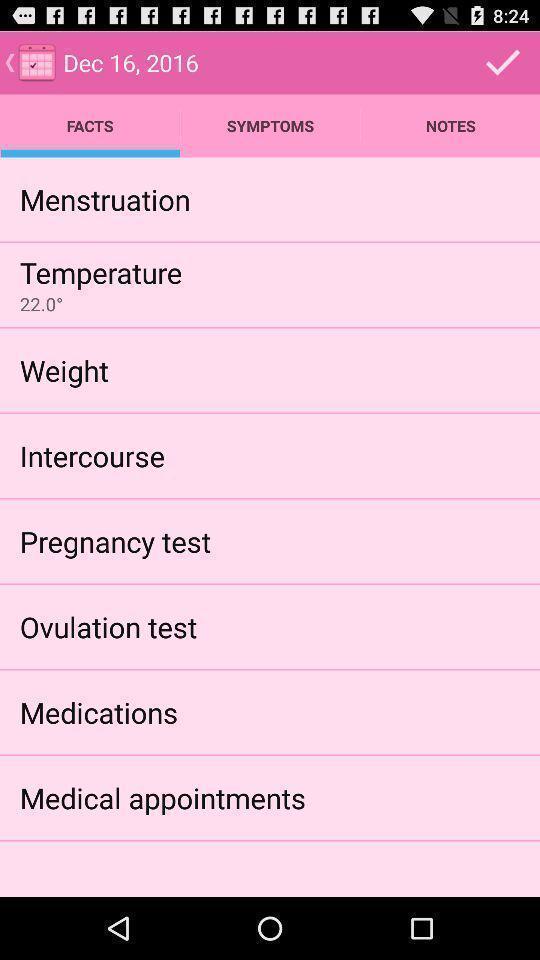What is the overall content of this screenshot? Page showing options with tests for treatment of conceiving women. 